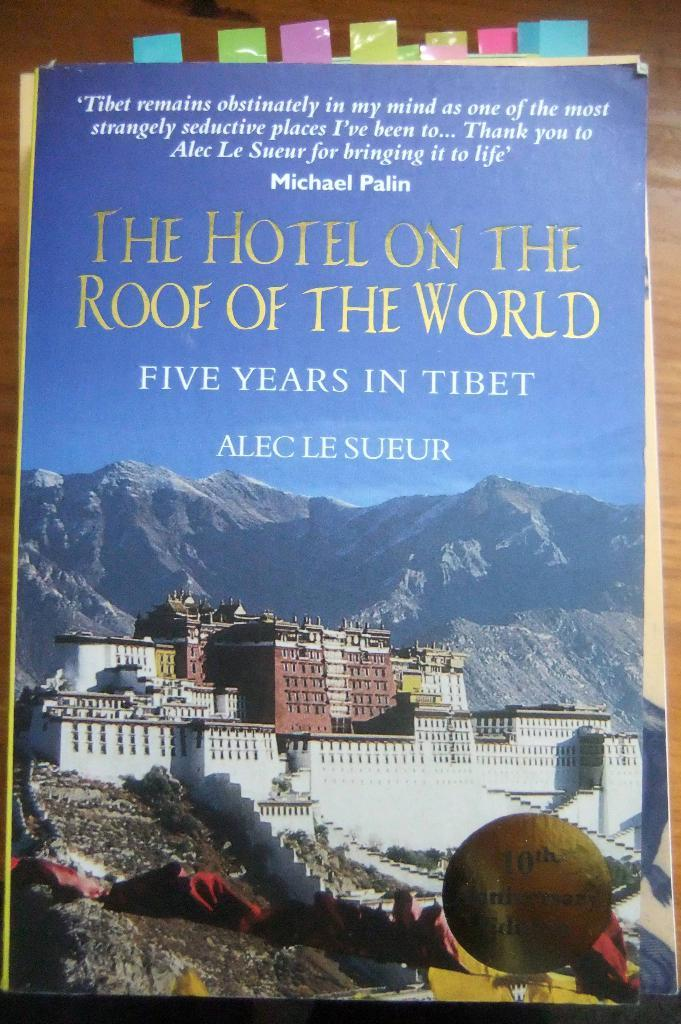<image>
Present a compact description of the photo's key features. A book titled, "The Hotel on the Roof of the World" has colored flags at the top. 